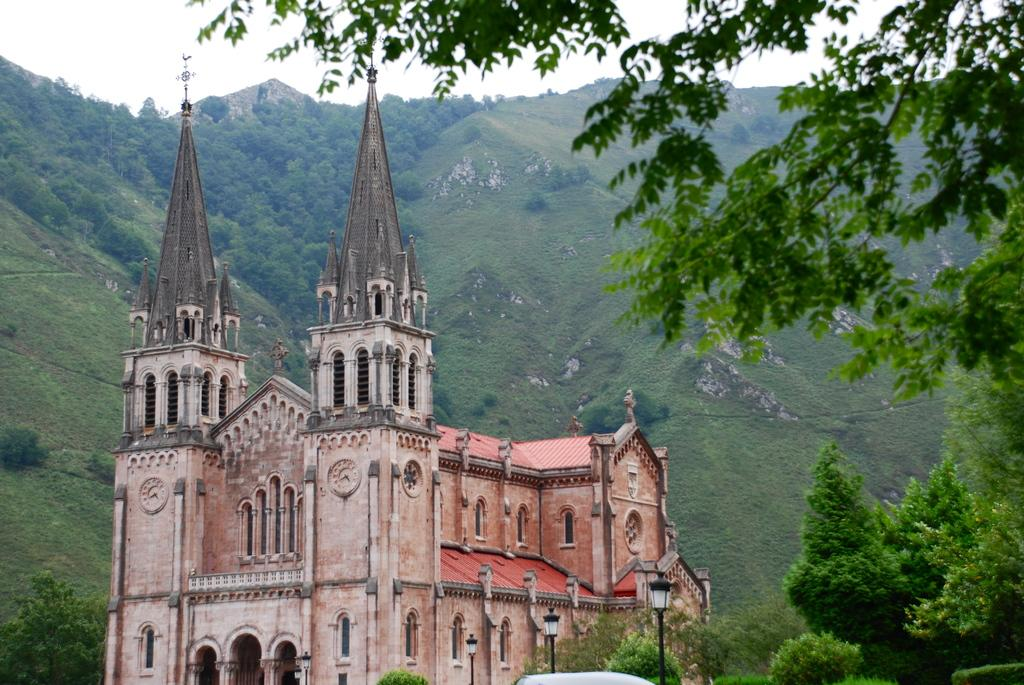What type of structure is present in the image? There is a building in the image. What other natural elements can be seen in the image? There are trees and mountains visible in the image. What is visible at the top of the image? The sky is visible at the top of the image. Can you tell me how many questions the toad in the image is asking? There is no toad present in the image, so it is not possible to determine how many questions the toad is asking. 